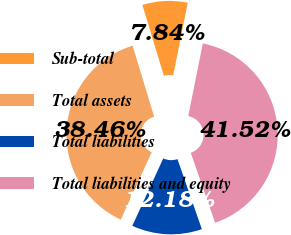Convert chart. <chart><loc_0><loc_0><loc_500><loc_500><pie_chart><fcel>Sub-total<fcel>Total assets<fcel>Total liabilities<fcel>Total liabilities and equity<nl><fcel>7.84%<fcel>38.46%<fcel>12.18%<fcel>41.52%<nl></chart> 